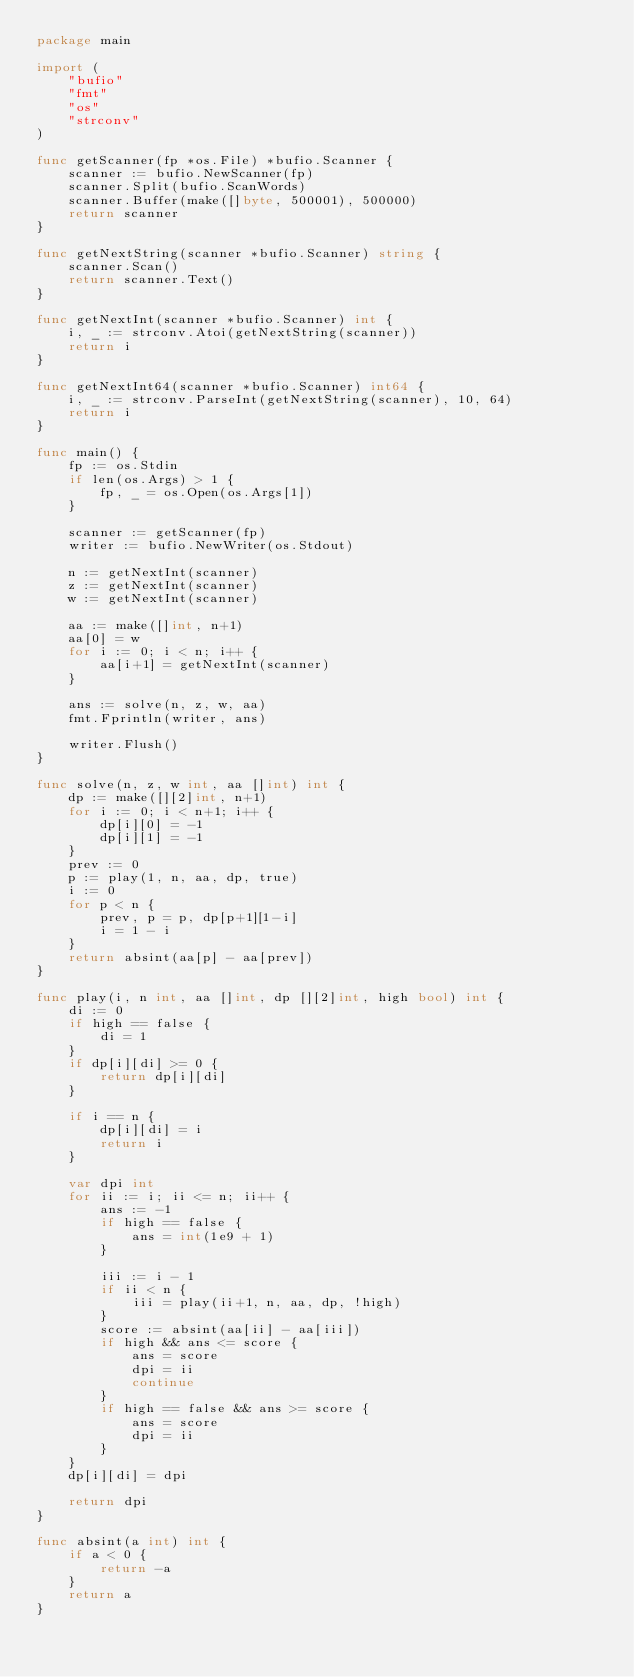Convert code to text. <code><loc_0><loc_0><loc_500><loc_500><_Go_>package main

import (
	"bufio"
	"fmt"
	"os"
	"strconv"
)

func getScanner(fp *os.File) *bufio.Scanner {
	scanner := bufio.NewScanner(fp)
	scanner.Split(bufio.ScanWords)
	scanner.Buffer(make([]byte, 500001), 500000)
	return scanner
}

func getNextString(scanner *bufio.Scanner) string {
	scanner.Scan()
	return scanner.Text()
}

func getNextInt(scanner *bufio.Scanner) int {
	i, _ := strconv.Atoi(getNextString(scanner))
	return i
}

func getNextInt64(scanner *bufio.Scanner) int64 {
	i, _ := strconv.ParseInt(getNextString(scanner), 10, 64)
	return i
}

func main() {
	fp := os.Stdin
	if len(os.Args) > 1 {
		fp, _ = os.Open(os.Args[1])
	}

	scanner := getScanner(fp)
	writer := bufio.NewWriter(os.Stdout)

	n := getNextInt(scanner)
	z := getNextInt(scanner)
	w := getNextInt(scanner)

	aa := make([]int, n+1)
	aa[0] = w
	for i := 0; i < n; i++ {
		aa[i+1] = getNextInt(scanner)
	}

	ans := solve(n, z, w, aa)
	fmt.Fprintln(writer, ans)

	writer.Flush()
}

func solve(n, z, w int, aa []int) int {
	dp := make([][2]int, n+1)
	for i := 0; i < n+1; i++ {
		dp[i][0] = -1
		dp[i][1] = -1
	}
	prev := 0
	p := play(1, n, aa, dp, true)
	i := 0
	for p < n {
		prev, p = p, dp[p+1][1-i]
		i = 1 - i
	}
	return absint(aa[p] - aa[prev])
}

func play(i, n int, aa []int, dp [][2]int, high bool) int {
	di := 0
	if high == false {
		di = 1
	}
	if dp[i][di] >= 0 {
		return dp[i][di]
	}

	if i == n {
		dp[i][di] = i
		return i
	}

	var dpi int
	for ii := i; ii <= n; ii++ {
		ans := -1
		if high == false {
			ans = int(1e9 + 1)
		}

		iii := i - 1
		if ii < n {
			iii = play(ii+1, n, aa, dp, !high)
		}
		score := absint(aa[ii] - aa[iii])
		if high && ans <= score {
			ans = score
			dpi = ii
			continue
		}
		if high == false && ans >= score {
			ans = score
			dpi = ii
		}
	}
	dp[i][di] = dpi

	return dpi
}

func absint(a int) int {
	if a < 0 {
		return -a
	}
	return a
}
</code> 